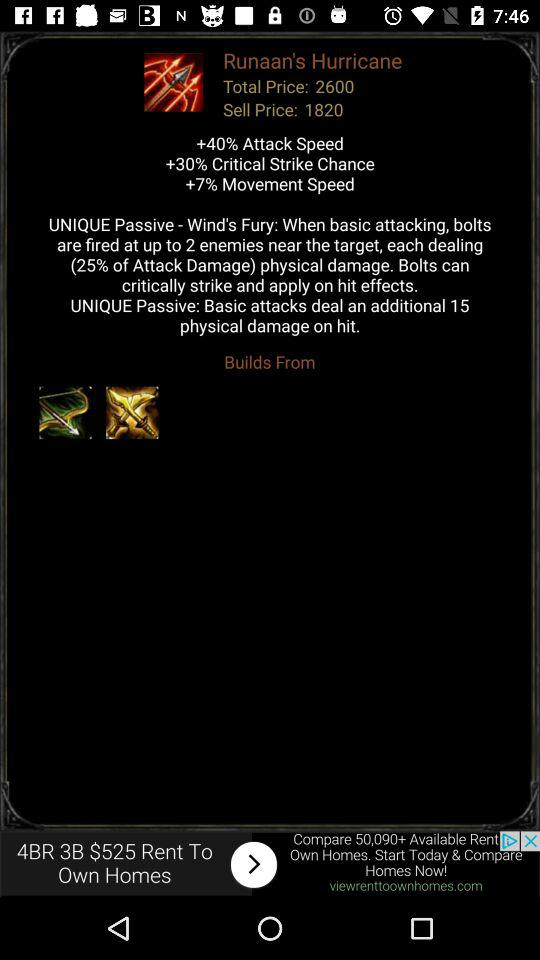What is the chance of hitting a critical strike? A critical strike has a +30% chance of hitting. 